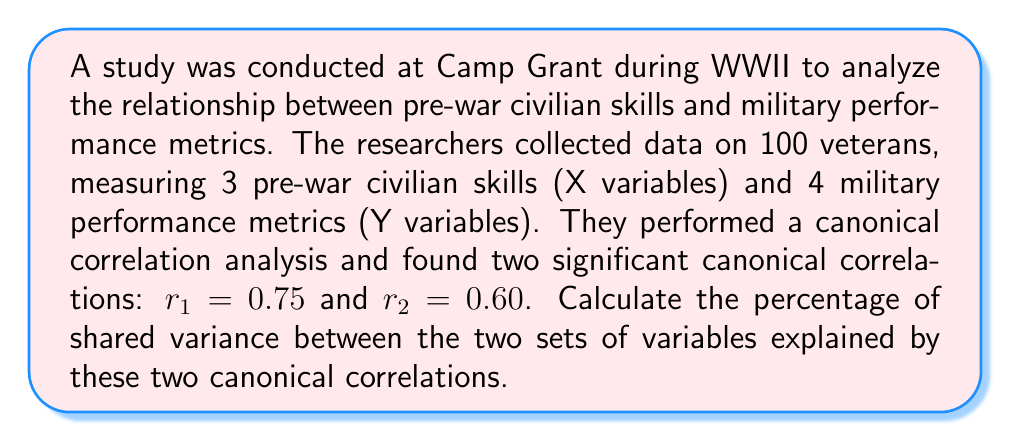What is the answer to this math problem? To solve this problem, we need to follow these steps:

1) In canonical correlation analysis, the squared canonical correlations represent the amount of shared variance between the two sets of variables for each canonical function.

2) To calculate the total shared variance explained by the significant canonical correlations, we need to sum the squared correlations.

3) For the first canonical correlation:
   $r_1^2 = 0.75^2 = 0.5625$ or 56.25%

4) For the second canonical correlation:
   $r_2^2 = 0.60^2 = 0.3600$ or 36.00%

5) The total shared variance is the sum of these squared correlations:
   $0.5625 + 0.3600 = 0.9225$ or 92.25%

6) To express this as a percentage, we multiply by 100:
   $0.9225 \times 100 = 92.25\%$

Therefore, the two significant canonical correlations explain 92.25% of the shared variance between the pre-war civilian skills and military performance metrics.
Answer: 92.25% 